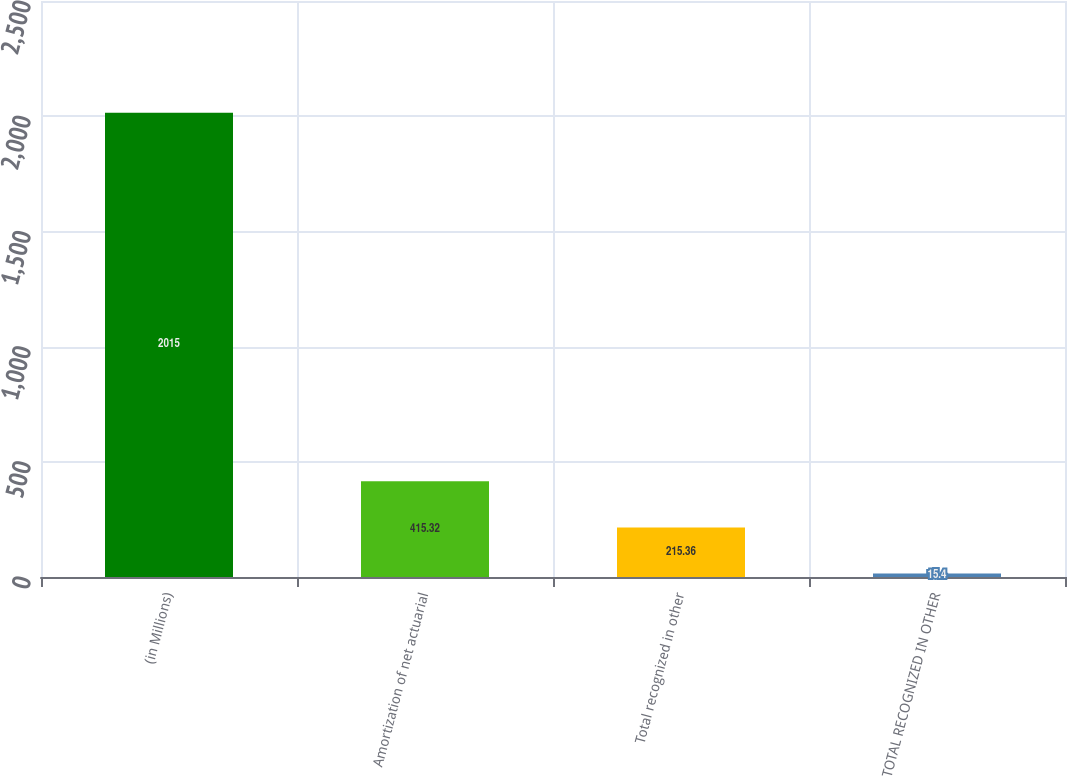Convert chart to OTSL. <chart><loc_0><loc_0><loc_500><loc_500><bar_chart><fcel>(in Millions)<fcel>Amortization of net actuarial<fcel>Total recognized in other<fcel>TOTAL RECOGNIZED IN OTHER<nl><fcel>2015<fcel>415.32<fcel>215.36<fcel>15.4<nl></chart> 